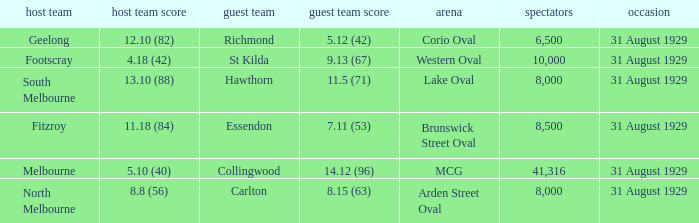What was the away team when the game was at corio oval? Richmond. 